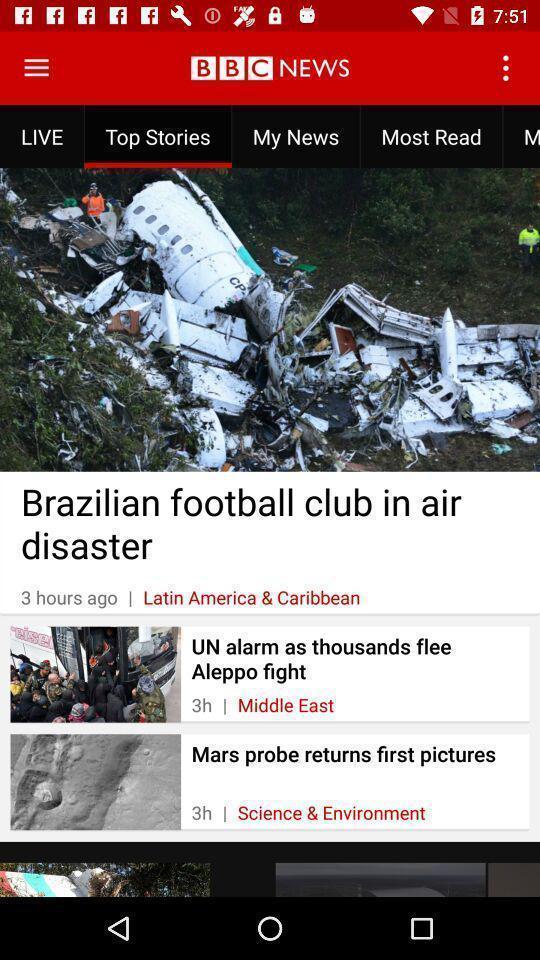Provide a textual representation of this image. Screen shows top stories in a live news app. 